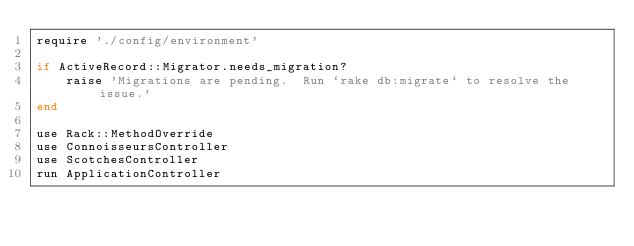Convert code to text. <code><loc_0><loc_0><loc_500><loc_500><_Ruby_>require './config/environment'

if ActiveRecord::Migrator.needs_migration?
	raise 'Migrations are pending.  Run `rake db:migrate` to resolve the issue.'
end

use Rack::MethodOverride
use ConnoisseursController
use ScotchesController
run ApplicationController
</code> 